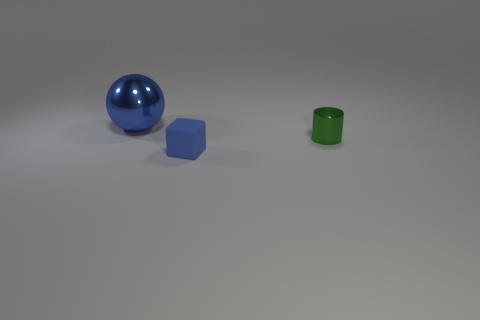Do the ball and the thing that is on the right side of the small blue cube have the same material?
Your response must be concise. Yes. There is a metallic object in front of the blue thing behind the tiny shiny cylinder; what number of large things are in front of it?
Provide a short and direct response. 0. Do the green metallic object and the blue object behind the small blue block have the same shape?
Give a very brief answer. No. There is a object that is both to the left of the tiny green metal object and behind the small blue matte object; what is its color?
Offer a very short reply. Blue. The blue object that is in front of the thing that is behind the metallic object on the right side of the blue sphere is made of what material?
Your answer should be very brief. Rubber. What material is the small cylinder?
Offer a very short reply. Metal. Is the color of the tiny shiny object the same as the big metal object?
Offer a very short reply. No. What number of other objects are the same material as the blue cube?
Give a very brief answer. 0. Are there the same number of big metallic objects in front of the blue metallic sphere and green cylinders?
Give a very brief answer. No. There is a metallic object that is behind the green thing; is it the same size as the green shiny cylinder?
Keep it short and to the point. No. 